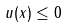Convert formula to latex. <formula><loc_0><loc_0><loc_500><loc_500>u ( x ) \leq 0</formula> 